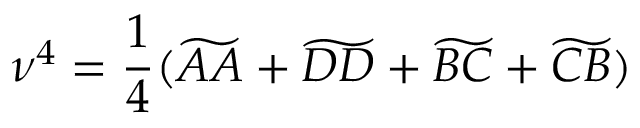<formula> <loc_0><loc_0><loc_500><loc_500>\nu ^ { 4 } = \frac { 1 } { 4 } ( \widetilde { A A } + \widetilde { D D } + \widetilde { B C } + \widetilde { C B } )</formula> 